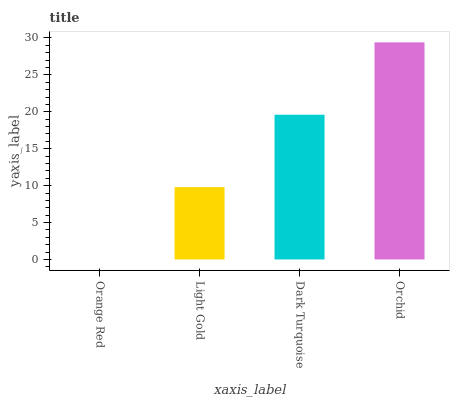Is Orange Red the minimum?
Answer yes or no. Yes. Is Orchid the maximum?
Answer yes or no. Yes. Is Light Gold the minimum?
Answer yes or no. No. Is Light Gold the maximum?
Answer yes or no. No. Is Light Gold greater than Orange Red?
Answer yes or no. Yes. Is Orange Red less than Light Gold?
Answer yes or no. Yes. Is Orange Red greater than Light Gold?
Answer yes or no. No. Is Light Gold less than Orange Red?
Answer yes or no. No. Is Dark Turquoise the high median?
Answer yes or no. Yes. Is Light Gold the low median?
Answer yes or no. Yes. Is Orchid the high median?
Answer yes or no. No. Is Orange Red the low median?
Answer yes or no. No. 